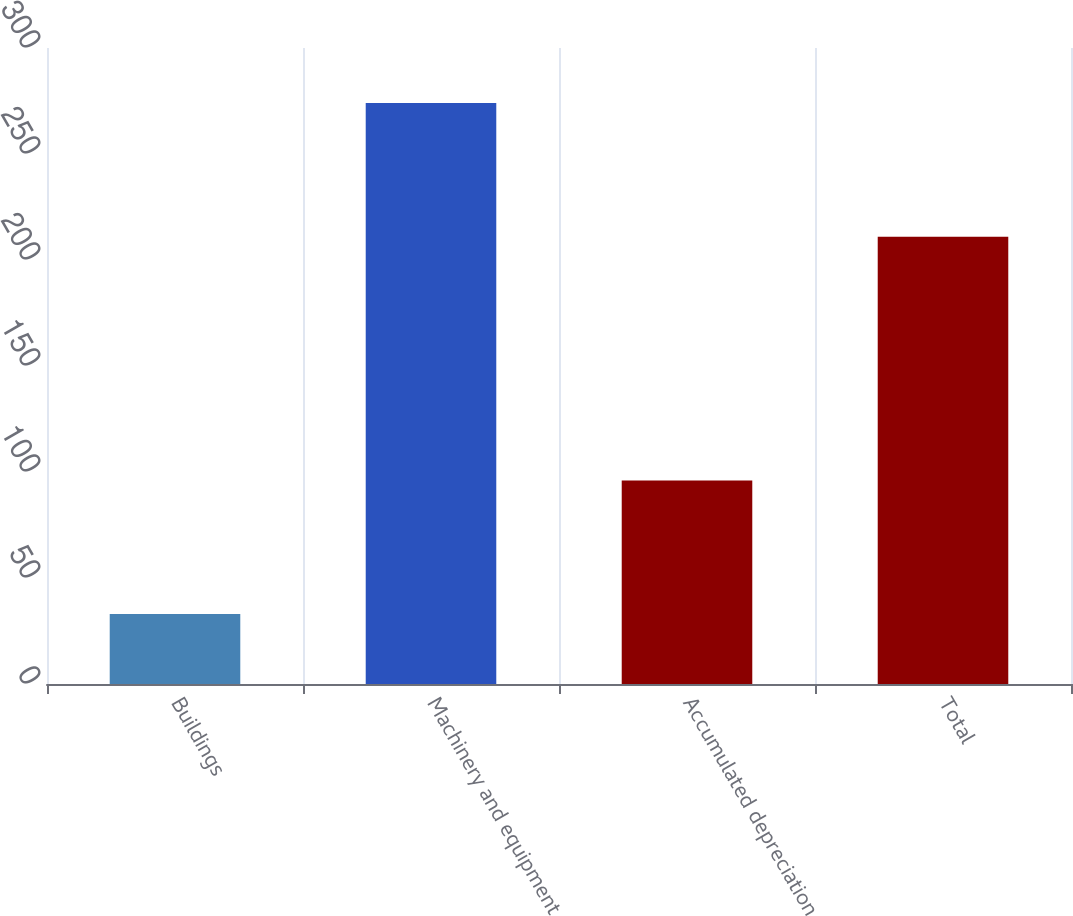<chart> <loc_0><loc_0><loc_500><loc_500><bar_chart><fcel>Buildings<fcel>Machinery and equipment<fcel>Accumulated depreciation<fcel>Total<nl><fcel>33<fcel>274<fcel>96<fcel>211<nl></chart> 